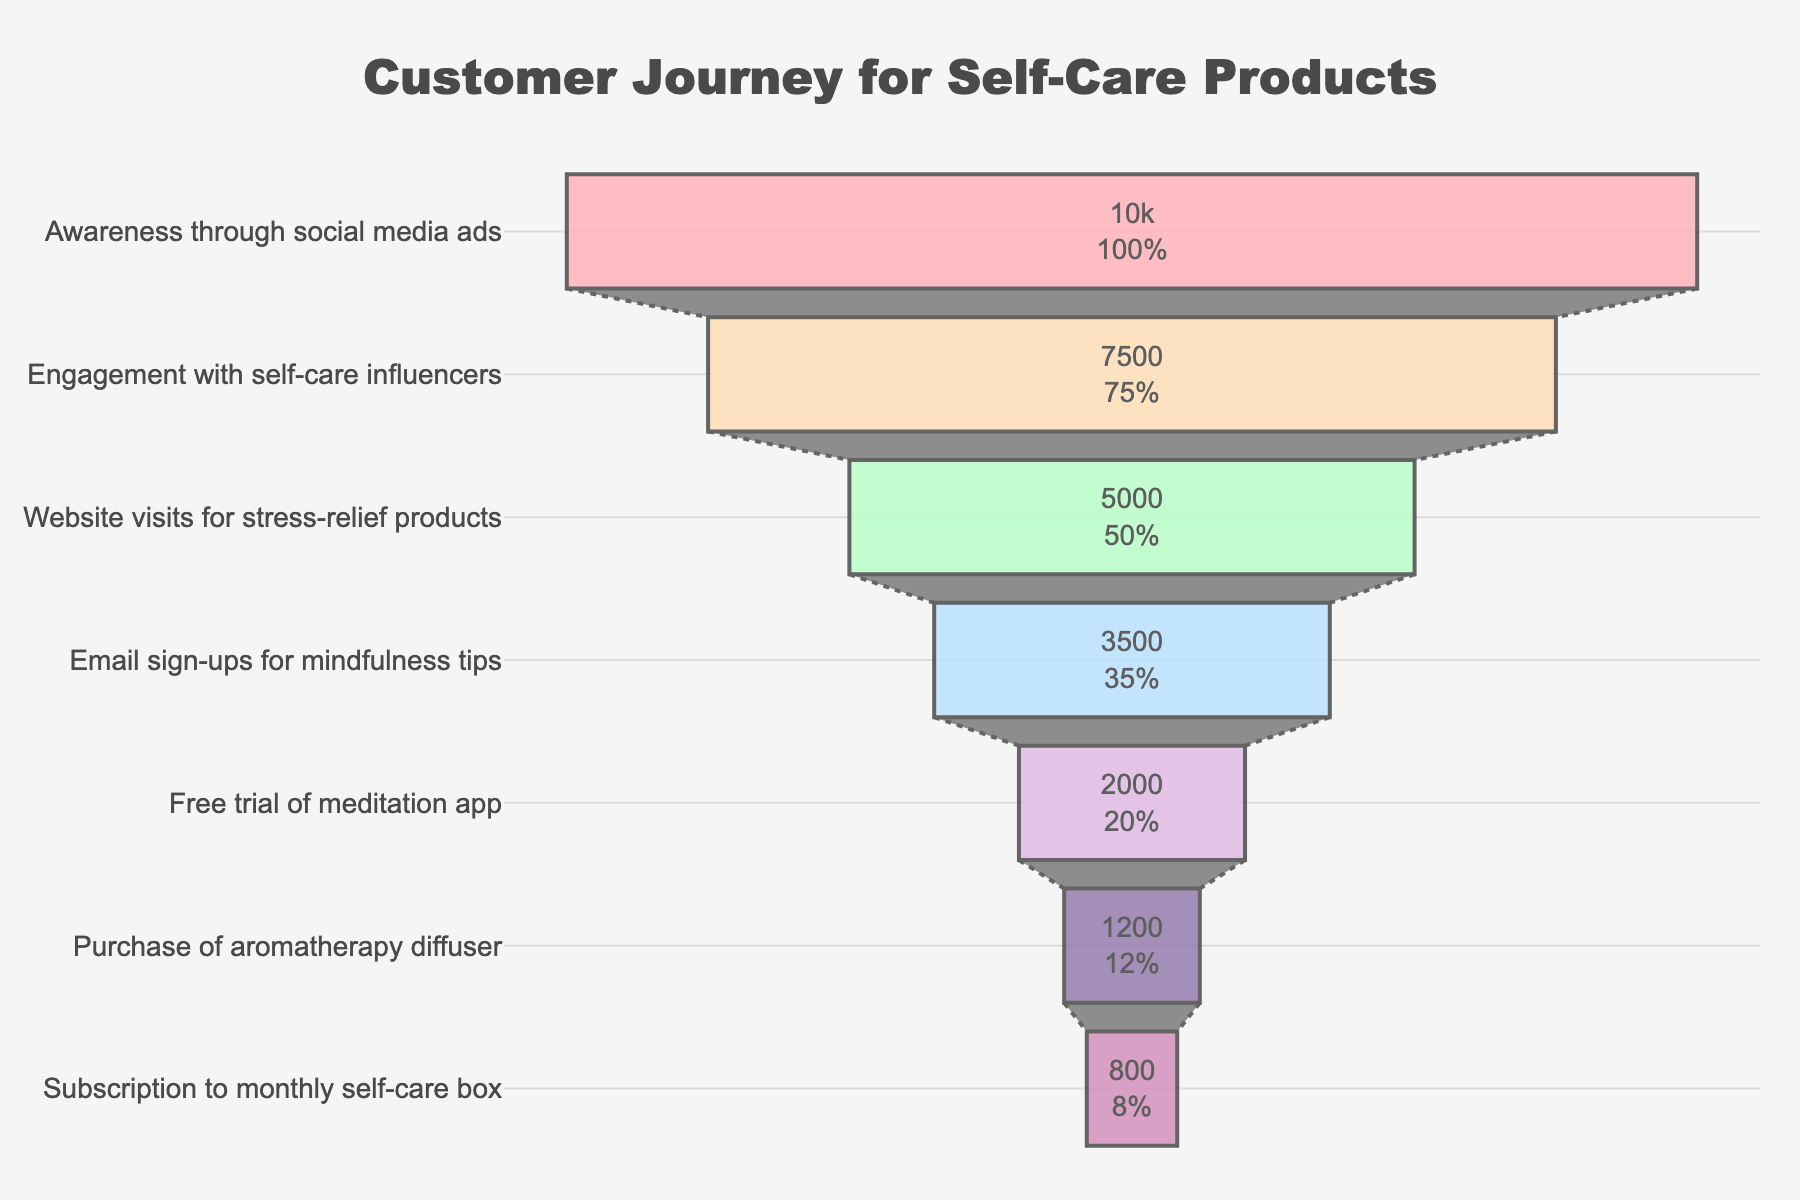How many stages are shown in the funnel chart? There are seven stages listed in the funnel chart ranging from awareness through social media ads to subscription to a monthly self-care box.
Answer: 7 What is the title of the funnel chart? The title of the funnel chart is prominently displayed at the top.
Answer: Customer Journey for Self-Care Products Which stage has the highest count? The count for each stage decreases as you move down the chart; therefore, the top stage has the highest count.
Answer: Awareness through social media ads What percentage of initial users purchased an aromatherapy diffuser? The funnel chart provides both the counts and the percentage relative to the initial users. The figure shows that 12% of the users end up purchasing the aromatherapy diffuser.
Answer: 12% How many users moved from website visits for stress-relief products to email sign-ups for mindfulness tips? To find this, subtract the count of email sign-ups from the count of website visits. 5000 - 3500 = 1500 users dropped off.
Answer: 1500 What is the decrease in user count from the free trial of the meditation app to the purchase of an aromatherapy diffuser? Subtract the count of purchases of the aromatherapy diffuser from the count of free trials of the meditation app. 2000 - 1200 = 800.
Answer: 800 Which stage has the smallest count and what is it? The smallest count is at the bottom of the funnel chart, indicating the final stage.
Answer: Subscription to monthly self-care box, 800 What is the total number of users who engaged with self-care influencers and visited the website for stress-relief products? Sum the counts for these two stages: 7500 + 5000 = 12500 users.
Answer: 12500 How does the number of users who sign up for emails compare to those who take the free trial of the meditation app? The counts for these two stages show email sign-ups are higher than free trials, 3500 vs 2000.
Answer: Email sign-ups are higher How much higher is the count for engagement with self-care influencers compared to purchasing an aromatherapy diffuser? To find the difference, subtract the purchase count from the engagement count. 7500 - 1200 = 6300.
Answer: 6300 